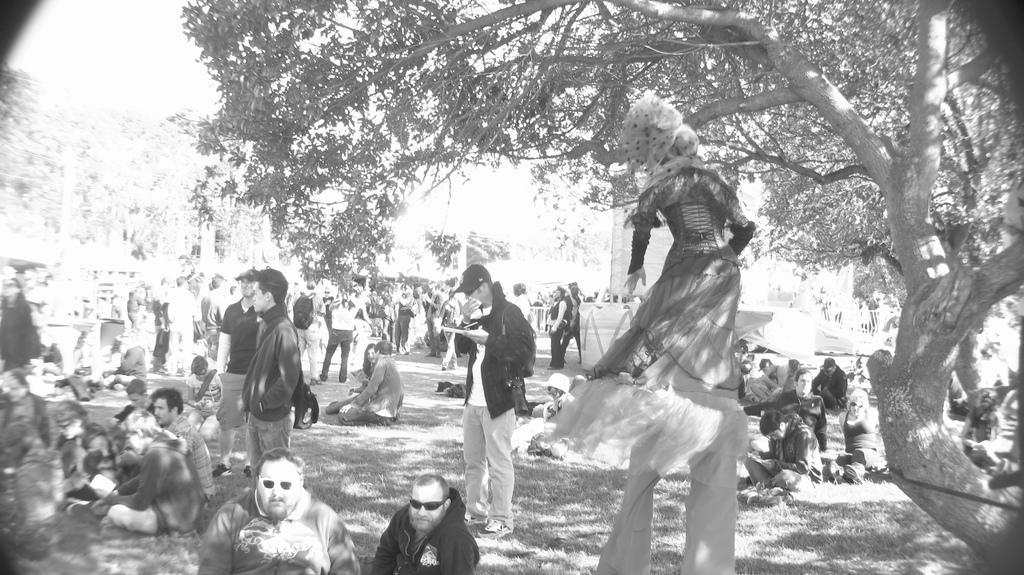How would you summarize this image in a sentence or two? This is a black and white image. On the left side, I can see many people on the ground. Few are sitting and few are standing. Here I can see a person is wearing costume and walking on the ground. On the right side, I can see a tree. 